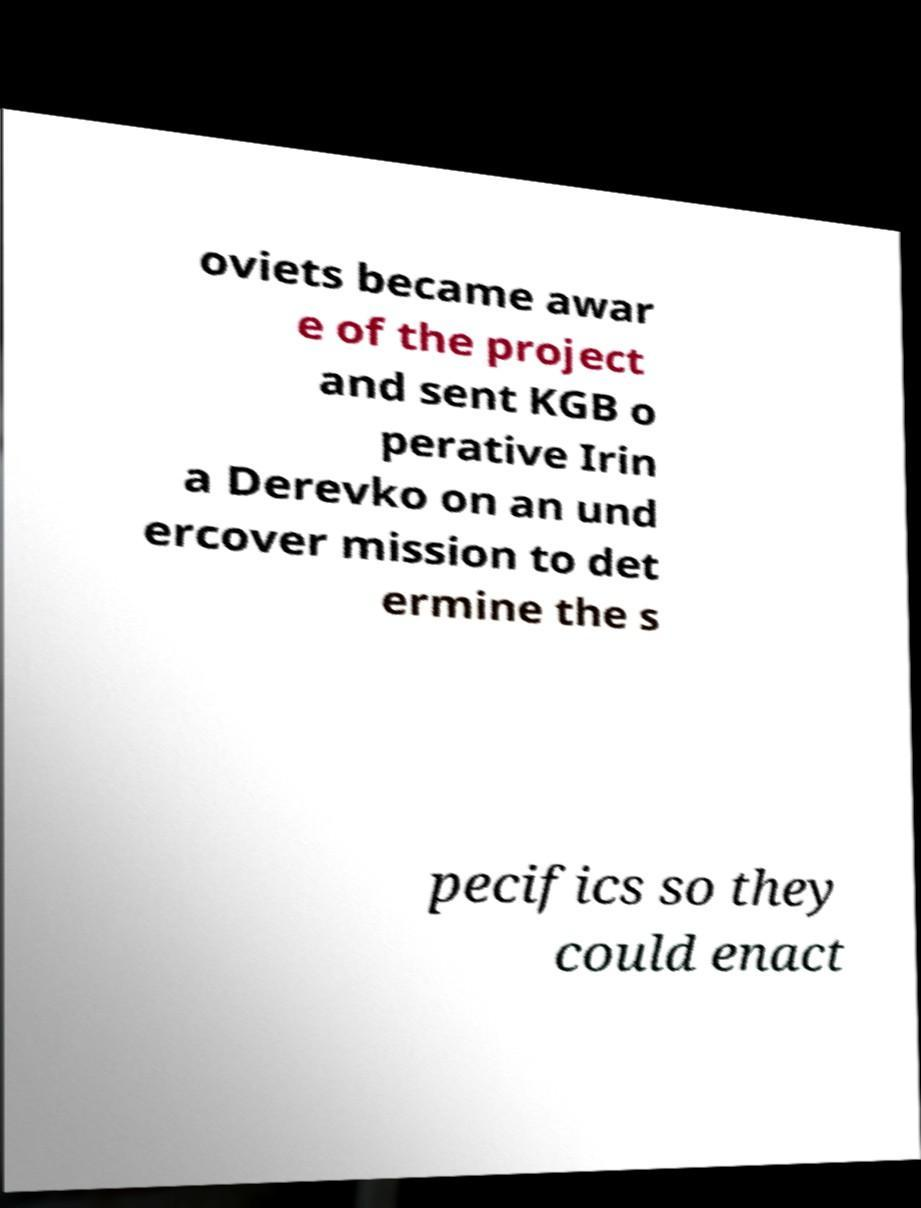What messages or text are displayed in this image? I need them in a readable, typed format. oviets became awar e of the project and sent KGB o perative Irin a Derevko on an und ercover mission to det ermine the s pecifics so they could enact 